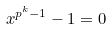<formula> <loc_0><loc_0><loc_500><loc_500>x ^ { p ^ { k } - 1 } - 1 = 0</formula> 